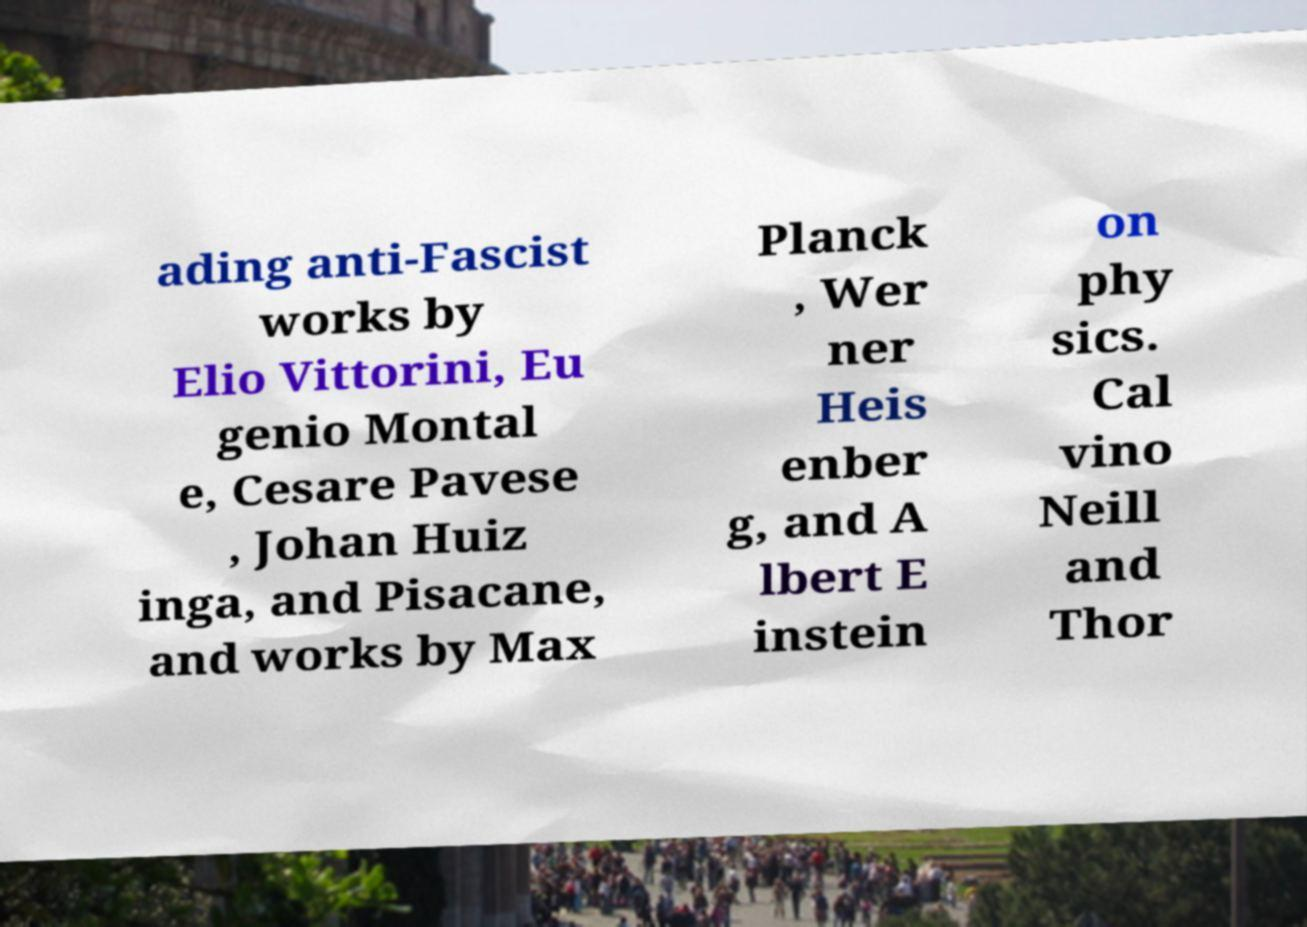Please read and relay the text visible in this image. What does it say? ading anti-Fascist works by Elio Vittorini, Eu genio Montal e, Cesare Pavese , Johan Huiz inga, and Pisacane, and works by Max Planck , Wer ner Heis enber g, and A lbert E instein on phy sics. Cal vino Neill and Thor 